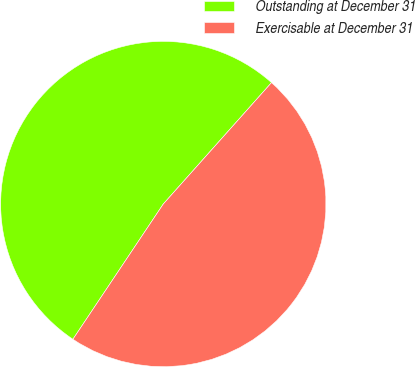Convert chart. <chart><loc_0><loc_0><loc_500><loc_500><pie_chart><fcel>Outstanding at December 31<fcel>Exercisable at December 31<nl><fcel>52.21%<fcel>47.79%<nl></chart> 